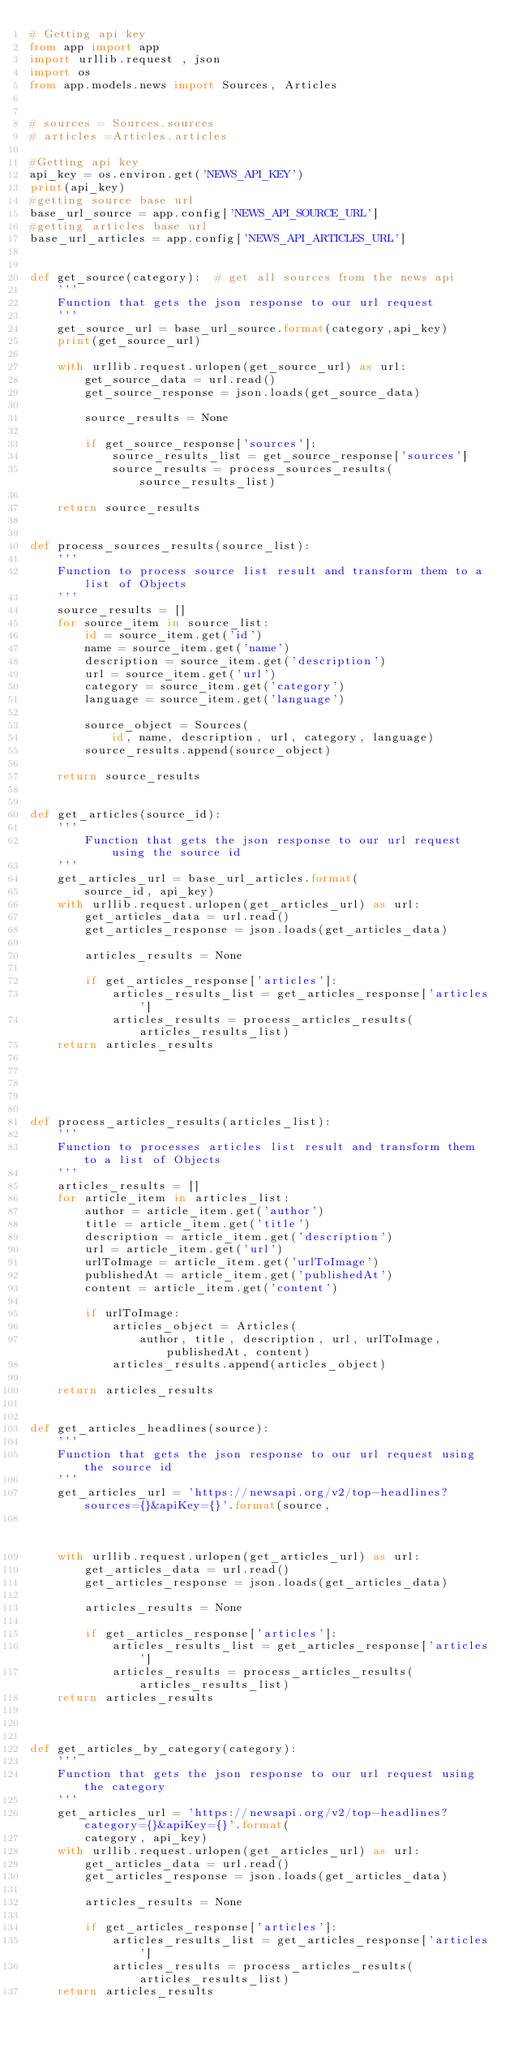Convert code to text. <code><loc_0><loc_0><loc_500><loc_500><_Python_># Getting api key
from app import app
import urllib.request , json
import os
from app.models.news import Sources, Articles


# sources = Sources.sources
# articles =Articles.articles

#Getting api key
api_key = os.environ.get('NEWS_API_KEY')
print(api_key)
#getting source base url
base_url_source = app.config['NEWS_API_SOURCE_URL']
#getting articles base url
base_url_articles = app.config['NEWS_API_ARTICLES_URL']


def get_source(category):  # get all sources from the news api
    '''
    Function that gets the json response to our url request
    '''
    get_source_url = base_url_source.format(category,api_key)
    print(get_source_url)

    with urllib.request.urlopen(get_source_url) as url:
        get_source_data = url.read()
        get_source_response = json.loads(get_source_data)

        source_results = None

        if get_source_response['sources']:
            source_results_list = get_source_response['sources']
            source_results = process_sources_results(source_results_list)

    return source_results


def process_sources_results(source_list):
    '''
    Function to process source list result and transform them to a list of Objects
    '''
    source_results = []
    for source_item in source_list:
        id = source_item.get('id')
        name = source_item.get('name')
        description = source_item.get('description')
        url = source_item.get('url')
        category = source_item.get('category')
        language = source_item.get('language')

        source_object = Sources(
            id, name, description, url, category, language)
        source_results.append(source_object)

    return source_results


def get_articles(source_id):
    '''
        Function that gets the json response to our url request using the source id
    '''
    get_articles_url = base_url_articles.format(
        source_id, api_key)
    with urllib.request.urlopen(get_articles_url) as url:
        get_articles_data = url.read()
        get_articles_response = json.loads(get_articles_data)

        articles_results = None

        if get_articles_response['articles']:
            articles_results_list = get_articles_response['articles']
            articles_results = process_articles_results(articles_results_list)
    return articles_results





def process_articles_results(articles_list):
    '''
    Function to processes articles list result and transform them to a list of Objects
    '''
    articles_results = []
    for article_item in articles_list:
        author = article_item.get('author')
        title = article_item.get('title')
        description = article_item.get('description')
        url = article_item.get('url')
        urlToImage = article_item.get('urlToImage')
        publishedAt = article_item.get('publishedAt')
        content = article_item.get('content')

        if urlToImage:
            articles_object = Articles(
                author, title, description, url, urlToImage, publishedAt, content)
            articles_results.append(articles_object)

    return articles_results


def get_articles_headlines(source):
    '''
    Function that gets the json response to our url request using the source id
    '''
    get_articles_url = 'https://newsapi.org/v2/top-headlines?sources={}&apiKey={}'.format(source,
                                                                                                      api_key)
    with urllib.request.urlopen(get_articles_url) as url:
        get_articles_data = url.read()
        get_articles_response = json.loads(get_articles_data)

        articles_results = None

        if get_articles_response['articles']:
            articles_results_list = get_articles_response['articles']
            articles_results = process_articles_results(articles_results_list)
    return articles_results



def get_articles_by_category(category):
    '''
    Function that gets the json response to our url request using the category 
    '''
    get_articles_url = 'https://newsapi.org/v2/top-headlines?category={}&apiKey={}'.format(
        category, api_key)
    with urllib.request.urlopen(get_articles_url) as url:
        get_articles_data = url.read()
        get_articles_response = json.loads(get_articles_data)

        articles_results = None

        if get_articles_response['articles']:
            articles_results_list = get_articles_response['articles']
            articles_results = process_articles_results(articles_results_list)
    return articles_results




   </code> 